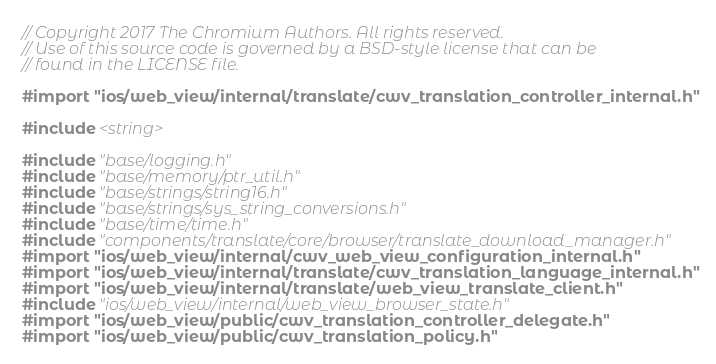Convert code to text. <code><loc_0><loc_0><loc_500><loc_500><_ObjectiveC_>// Copyright 2017 The Chromium Authors. All rights reserved.
// Use of this source code is governed by a BSD-style license that can be
// found in the LICENSE file.

#import "ios/web_view/internal/translate/cwv_translation_controller_internal.h"

#include <string>

#include "base/logging.h"
#include "base/memory/ptr_util.h"
#include "base/strings/string16.h"
#include "base/strings/sys_string_conversions.h"
#include "base/time/time.h"
#include "components/translate/core/browser/translate_download_manager.h"
#import "ios/web_view/internal/cwv_web_view_configuration_internal.h"
#import "ios/web_view/internal/translate/cwv_translation_language_internal.h"
#import "ios/web_view/internal/translate/web_view_translate_client.h"
#include "ios/web_view/internal/web_view_browser_state.h"
#import "ios/web_view/public/cwv_translation_controller_delegate.h"
#import "ios/web_view/public/cwv_translation_policy.h"</code> 